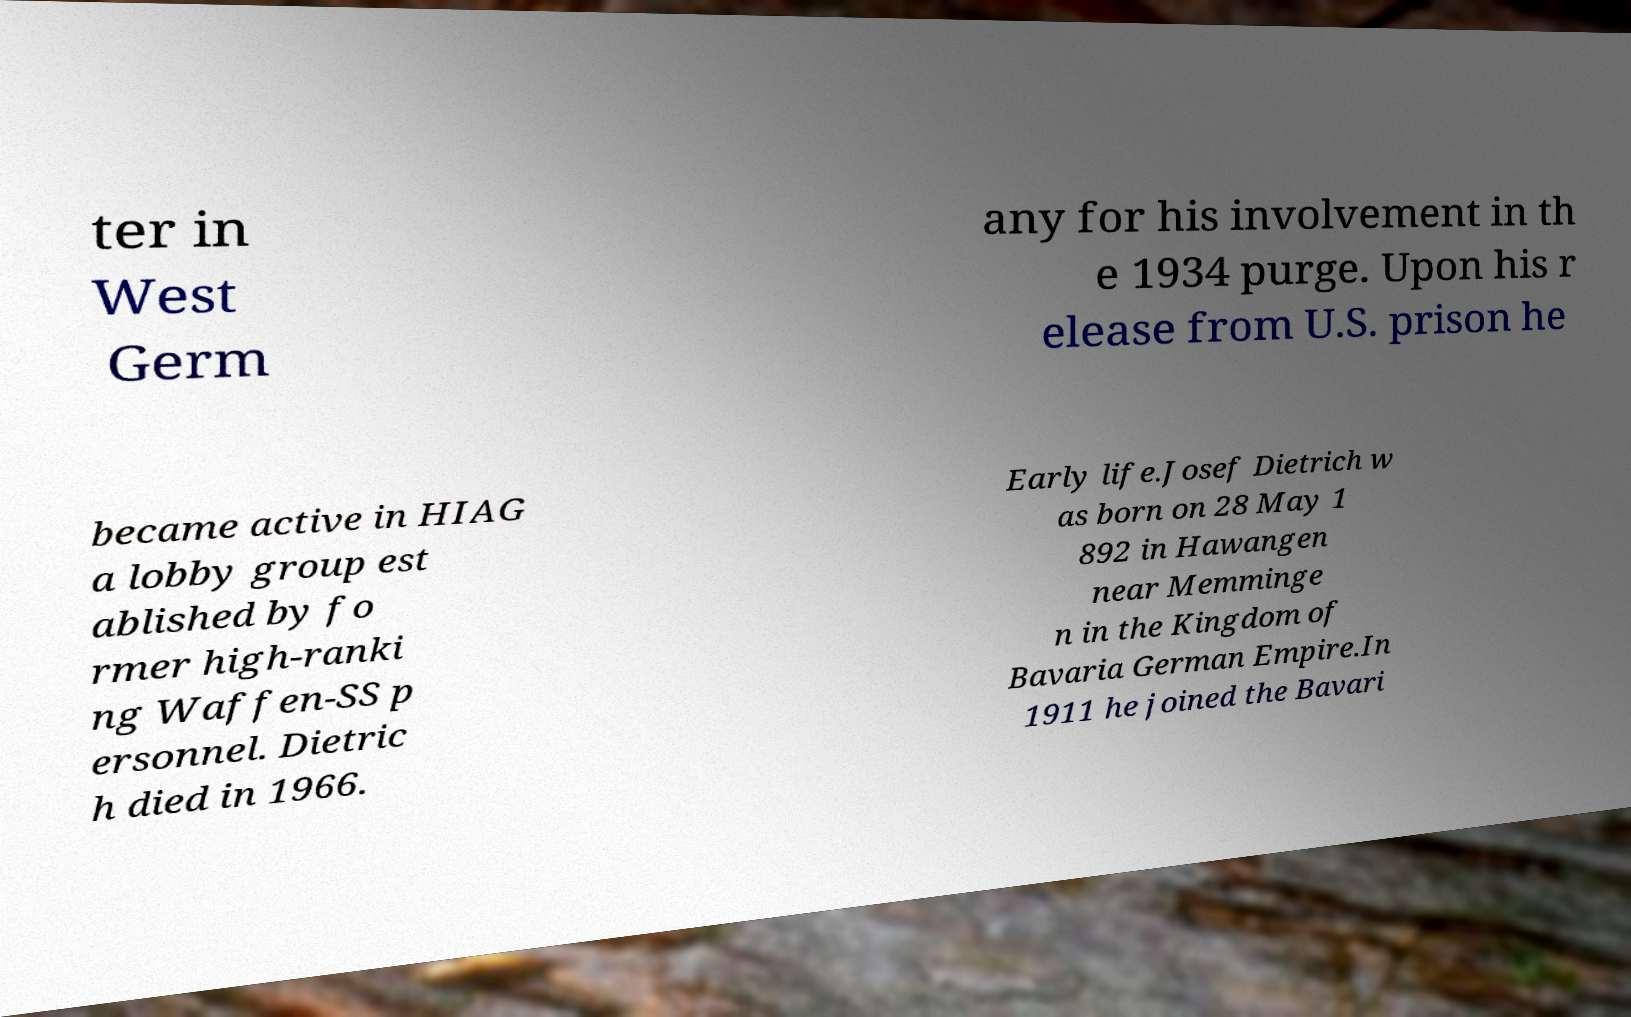Please read and relay the text visible in this image. What does it say? ter in West Germ any for his involvement in th e 1934 purge. Upon his r elease from U.S. prison he became active in HIAG a lobby group est ablished by fo rmer high-ranki ng Waffen-SS p ersonnel. Dietric h died in 1966. Early life.Josef Dietrich w as born on 28 May 1 892 in Hawangen near Memminge n in the Kingdom of Bavaria German Empire.In 1911 he joined the Bavari 